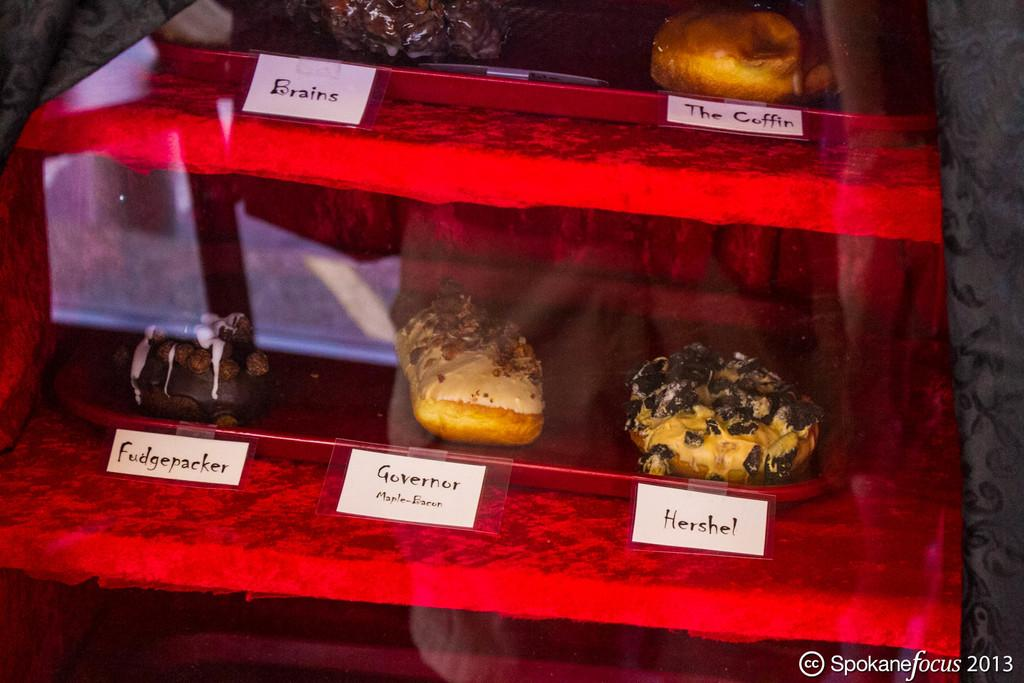<image>
Present a compact description of the photo's key features. Among the pastries displayed here are the coffin and governor. 